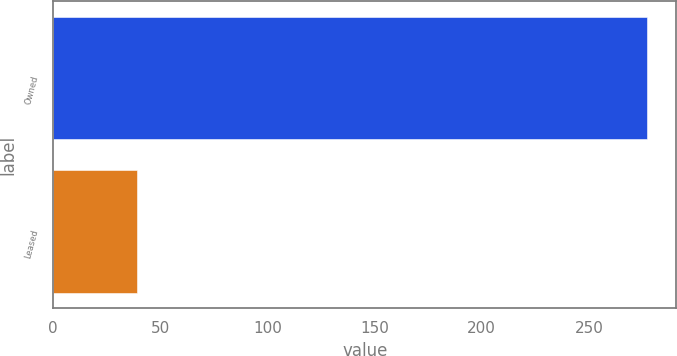Convert chart to OTSL. <chart><loc_0><loc_0><loc_500><loc_500><bar_chart><fcel>Owned<fcel>Leased<nl><fcel>277<fcel>39<nl></chart> 